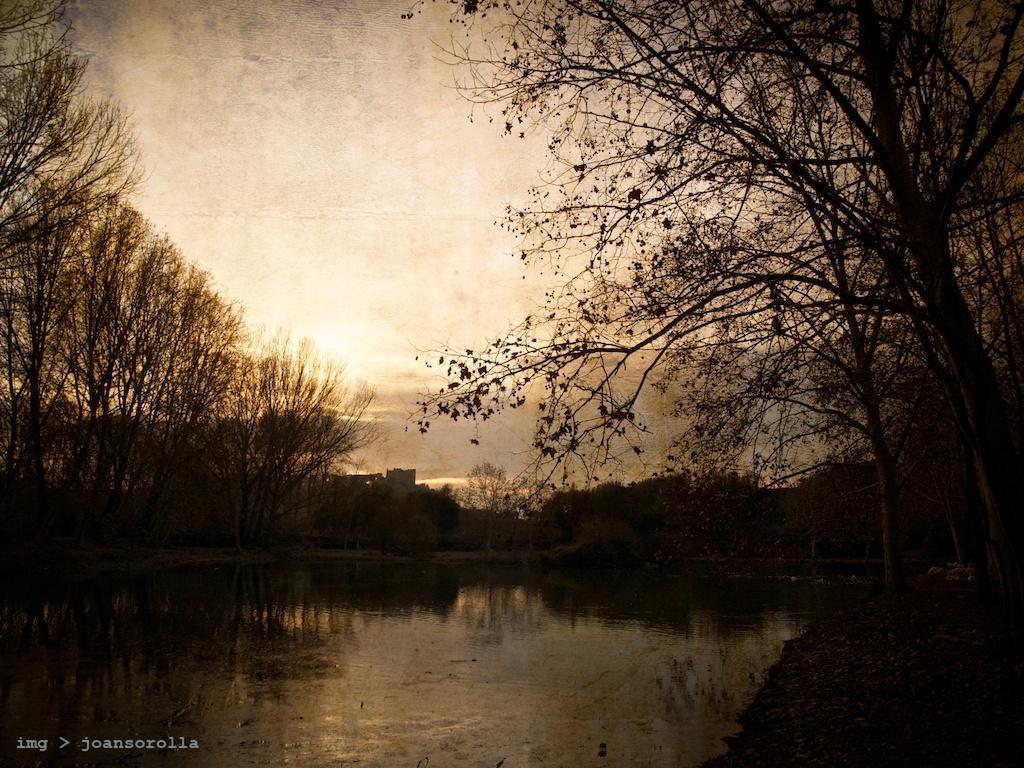Please provide a concise description of this image. This picture is clicked outside. In the foreground there is a water body and we can see the plants and trees. In the background there is a sky and some other objects. In the bottom left corner there is a text on the image. 